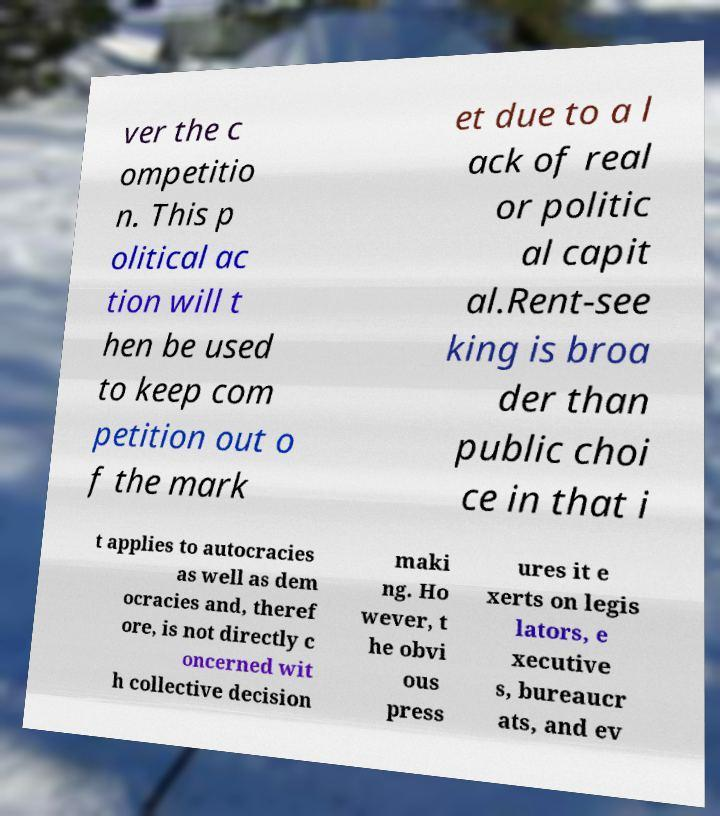For documentation purposes, I need the text within this image transcribed. Could you provide that? ver the c ompetitio n. This p olitical ac tion will t hen be used to keep com petition out o f the mark et due to a l ack of real or politic al capit al.Rent-see king is broa der than public choi ce in that i t applies to autocracies as well as dem ocracies and, theref ore, is not directly c oncerned wit h collective decision maki ng. Ho wever, t he obvi ous press ures it e xerts on legis lators, e xecutive s, bureaucr ats, and ev 